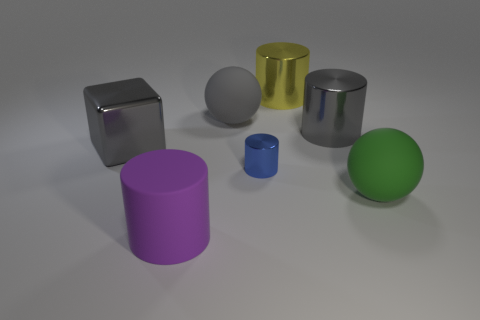Subtract all tiny shiny cylinders. How many cylinders are left? 3 Add 3 yellow rubber spheres. How many objects exist? 10 Subtract all purple cylinders. How many cylinders are left? 3 Subtract all balls. How many objects are left? 5 Subtract all small blue objects. Subtract all gray objects. How many objects are left? 3 Add 4 metal blocks. How many metal blocks are left? 5 Add 3 big metal objects. How many big metal objects exist? 6 Subtract 0 red blocks. How many objects are left? 7 Subtract 1 balls. How many balls are left? 1 Subtract all red blocks. Subtract all cyan cylinders. How many blocks are left? 1 